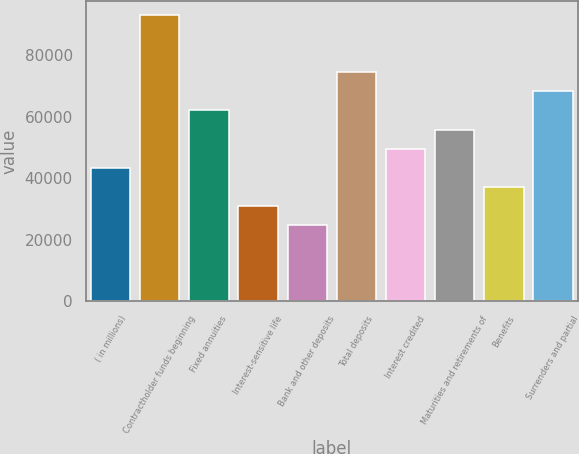Convert chart to OTSL. <chart><loc_0><loc_0><loc_500><loc_500><bar_chart><fcel>( in millions)<fcel>Contractholder funds beginning<fcel>Fixed annuities<fcel>Interest-sensitive life<fcel>Bank and other deposits<fcel>Total deposits<fcel>Interest credited<fcel>Maturities and retirements of<fcel>Benefits<fcel>Surrenders and partial<nl><fcel>43425.6<fcel>93040<fcel>62031<fcel>31022<fcel>24820.2<fcel>74434.6<fcel>49627.4<fcel>55829.2<fcel>37223.8<fcel>68232.8<nl></chart> 